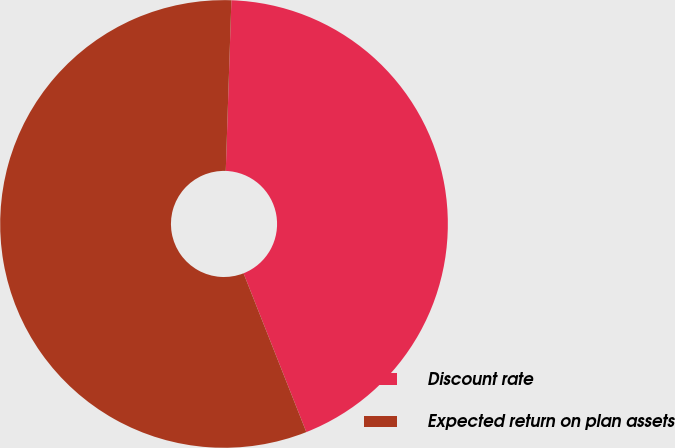<chart> <loc_0><loc_0><loc_500><loc_500><pie_chart><fcel>Discount rate<fcel>Expected return on plan assets<nl><fcel>43.48%<fcel>56.52%<nl></chart> 